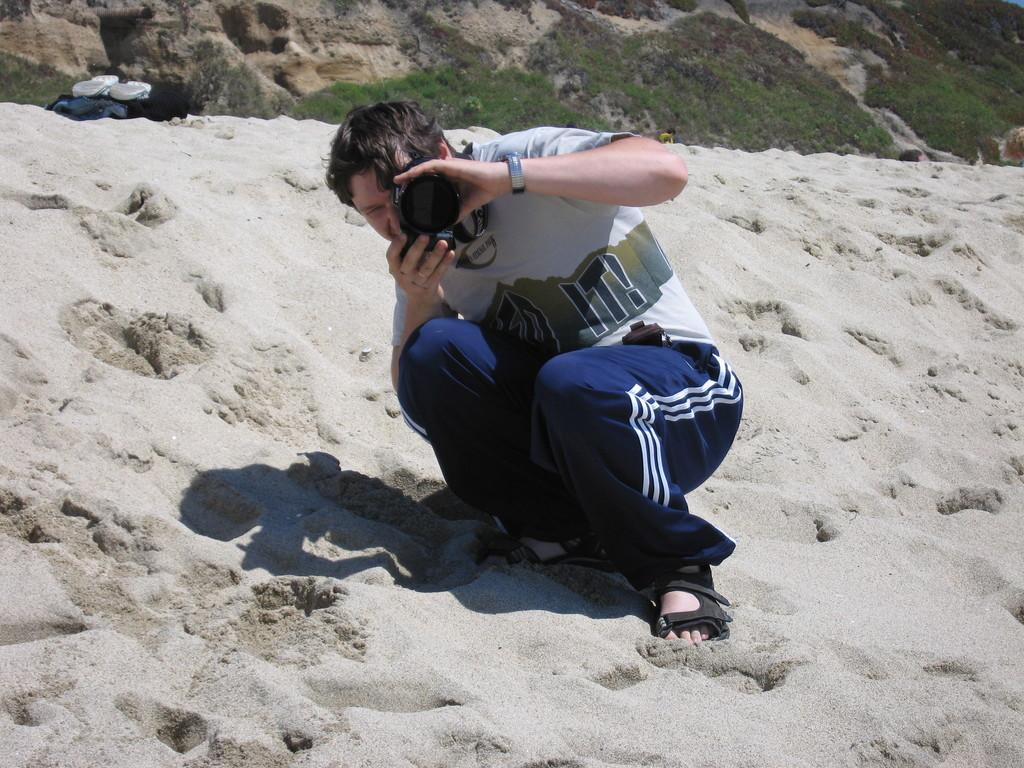Who is present in the image? There is a man in the image. What is the man doing in the image? The man is sitting on the sand in the image. What is the man holding in the image? The man is holding a camera in the image. What can be seen in the background of the image? There are plants on a hill in the background of the image. What type of steel is the dog made of in the image? There is no dog present in the image, let alone one made of steel. 